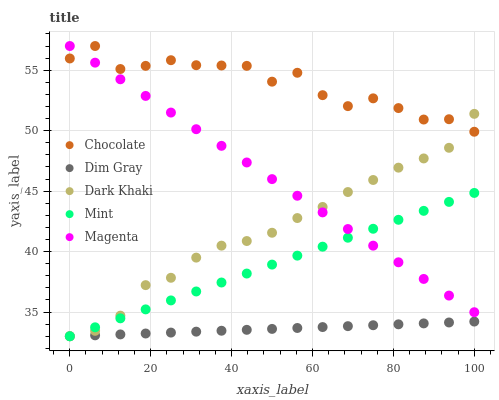Does Dim Gray have the minimum area under the curve?
Answer yes or no. Yes. Does Chocolate have the maximum area under the curve?
Answer yes or no. Yes. Does Magenta have the minimum area under the curve?
Answer yes or no. No. Does Magenta have the maximum area under the curve?
Answer yes or no. No. Is Magenta the smoothest?
Answer yes or no. Yes. Is Chocolate the roughest?
Answer yes or no. Yes. Is Chocolate the smoothest?
Answer yes or no. No. Is Mint the roughest?
Answer yes or no. No. Does Dark Khaki have the lowest value?
Answer yes or no. Yes. Does Magenta have the lowest value?
Answer yes or no. No. Does Chocolate have the highest value?
Answer yes or no. Yes. Does Dim Gray have the highest value?
Answer yes or no. No. Is Dim Gray less than Chocolate?
Answer yes or no. Yes. Is Chocolate greater than Dim Gray?
Answer yes or no. Yes. Does Chocolate intersect Dark Khaki?
Answer yes or no. Yes. Is Chocolate less than Dark Khaki?
Answer yes or no. No. Is Chocolate greater than Dark Khaki?
Answer yes or no. No. Does Dim Gray intersect Chocolate?
Answer yes or no. No. 